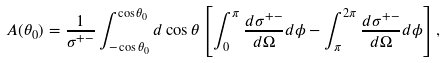<formula> <loc_0><loc_0><loc_500><loc_500>A ( \theta _ { 0 } ) = \frac { 1 } { \sigma ^ { + - } } \int _ { - \cos \theta _ { 0 } } ^ { \cos \theta _ { 0 } } d \cos \theta \left [ \int _ { 0 } ^ { \pi } \frac { d \sigma ^ { + - } } { d \Omega } d \phi - \int _ { \pi } ^ { 2 \pi } \frac { d \sigma ^ { + - } } { d \Omega } d \phi \right ] ,</formula> 